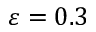Convert formula to latex. <formula><loc_0><loc_0><loc_500><loc_500>\varepsilon = 0 . 3</formula> 